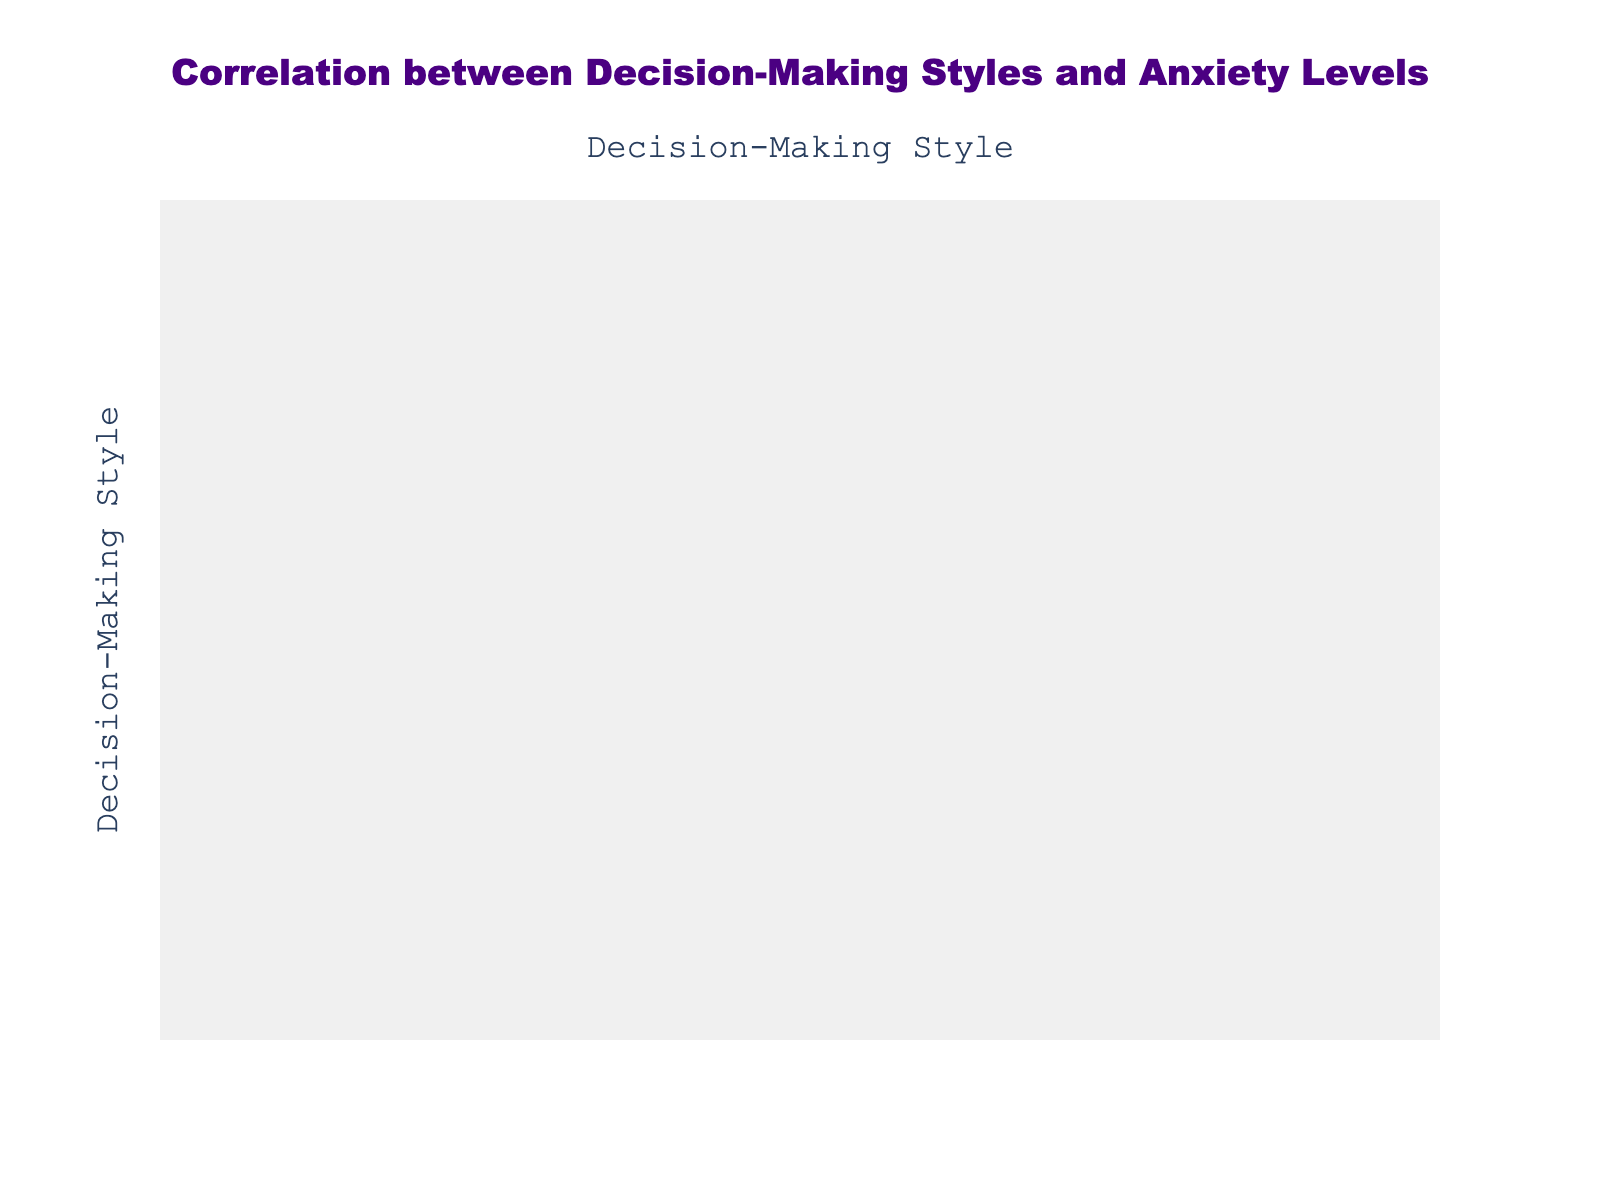What is the correlation between Analytical and Directive decision-making styles regarding anxiety levels? To find this, we look at the specific cell in the correlation table where Analytical and Directive intersect. We read the value, which indicates the strength and direction of the relationship between these two styles.
Answer: [value from table] What is the average anxiety level for patients using the Conceptual decision-making style? The anxiety levels for the Conceptual decision-making style are 6, 9, 7, 10, and 8. To find the average, we sum these values (6 + 9 + 7 + 10 + 8 = 40) and then divide by the count of values (40/5 = 8).
Answer: 8 Is there a strong positive correlation between Behavioral and Analytical decision-making styles? To determine this, we look at the correlation value in the table for Behavioral and Analytical. If the value is close to +1, we can conclude there is a strong positive correlation.
Answer: [Yes/No based on table] What is the difference in average anxiety levels between Directive and Behavioral decision-making styles? First, we find the average anxiety level for Directive (4, 3, 2, 3, 4) which equals 3.2. Then, we find the average for Behavioral (8, 6, 8, 7, 5) which is 6.8. The difference is 6.8 - 3.2 = 3.6.
Answer: 3.6 How many decision-making styles have an average anxiety level greater than 6? We examine the average values of anxiety levels for each decision-making style from the table. By counting how many of these averages are greater than 6, we find that Conceptual and Behavioral fit this criterion (with average levels 8).
Answer: 2 What is the correlation coefficient between Directive and Conceptual decision-making styles? We locate the intersection of the Directive and Conceptual styles in the correlation table and read the corresponding value. This value represents the correlation coefficient between the two styles.
Answer: [value from table] Are patients who use the Analytical decision-making style consistently experiencing lower anxiety than those using Directive? We compare the average anxiety levels; Analytical (5) is higher than Directive (4). Since Analytical patients generally have higher anxiety levels, the answer is no.
Answer: No What is the highest recorded anxiety level among patients who have a Behavioral decision-making style? To find this, we look at the anxiety levels corresponding to Behavioral style: 8, 6, 8, 7, and 5. The highest number in this set is 8.
Answer: 8 Which decision-making style has the lowest anxiety level based on the data? We compare the average anxiety levels of all decision-making styles to see which one has the minimum average. Looking at the averages, Directive has the lowest average anxiety level of 3.6.
Answer: Directive 